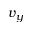<formula> <loc_0><loc_0><loc_500><loc_500>v _ { y }</formula> 